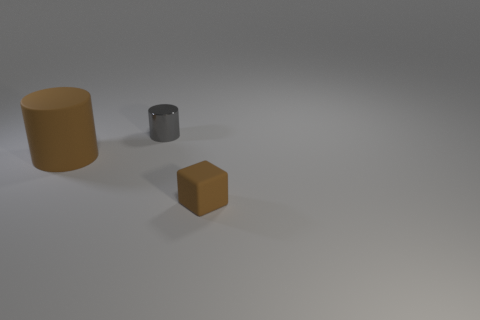Add 3 shiny things. How many objects exist? 6 Subtract all cubes. How many objects are left? 2 Add 2 large brown matte cylinders. How many large brown matte cylinders exist? 3 Subtract 0 blue balls. How many objects are left? 3 Subtract all tiny gray shiny blocks. Subtract all tiny gray metallic cylinders. How many objects are left? 2 Add 2 tiny shiny objects. How many tiny shiny objects are left? 3 